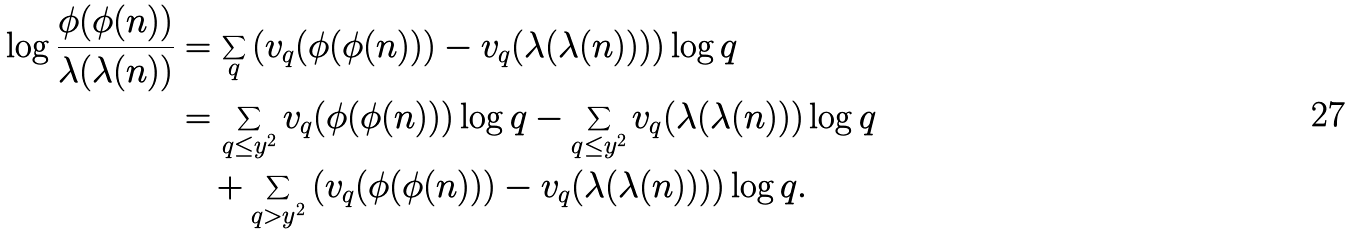Convert formula to latex. <formula><loc_0><loc_0><loc_500><loc_500>\log \frac { \phi ( \phi ( n ) ) } { \lambda ( \lambda ( n ) ) } & = \sum _ { q } \left ( v _ { q } ( \phi ( \phi ( n ) ) ) - v _ { q } ( \lambda ( \lambda ( n ) ) ) \right ) \log q \\ & = \sum _ { q \leq y ^ { 2 } } v _ { q } ( \phi ( \phi ( n ) ) ) \log q - \sum _ { q \leq y ^ { 2 } } v _ { q } ( \lambda ( \lambda ( n ) ) ) \log q \\ & \quad + \sum _ { q > y ^ { 2 } } \left ( v _ { q } ( \phi ( \phi ( n ) ) ) - v _ { q } ( \lambda ( \lambda ( n ) ) ) \right ) \log q .</formula> 